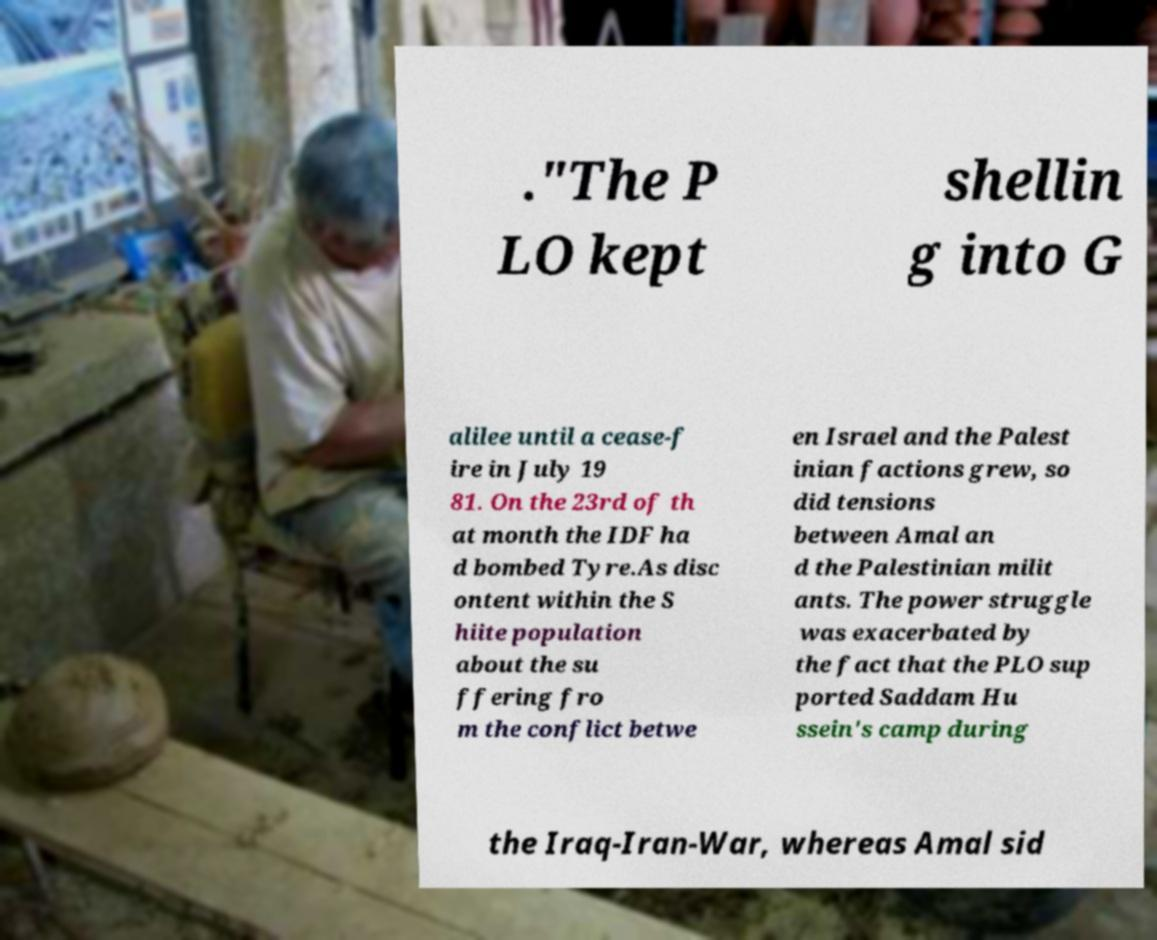Can you accurately transcribe the text from the provided image for me? ."The P LO kept shellin g into G alilee until a cease-f ire in July 19 81. On the 23rd of th at month the IDF ha d bombed Tyre.As disc ontent within the S hiite population about the su ffering fro m the conflict betwe en Israel and the Palest inian factions grew, so did tensions between Amal an d the Palestinian milit ants. The power struggle was exacerbated by the fact that the PLO sup ported Saddam Hu ssein's camp during the Iraq-Iran-War, whereas Amal sid 